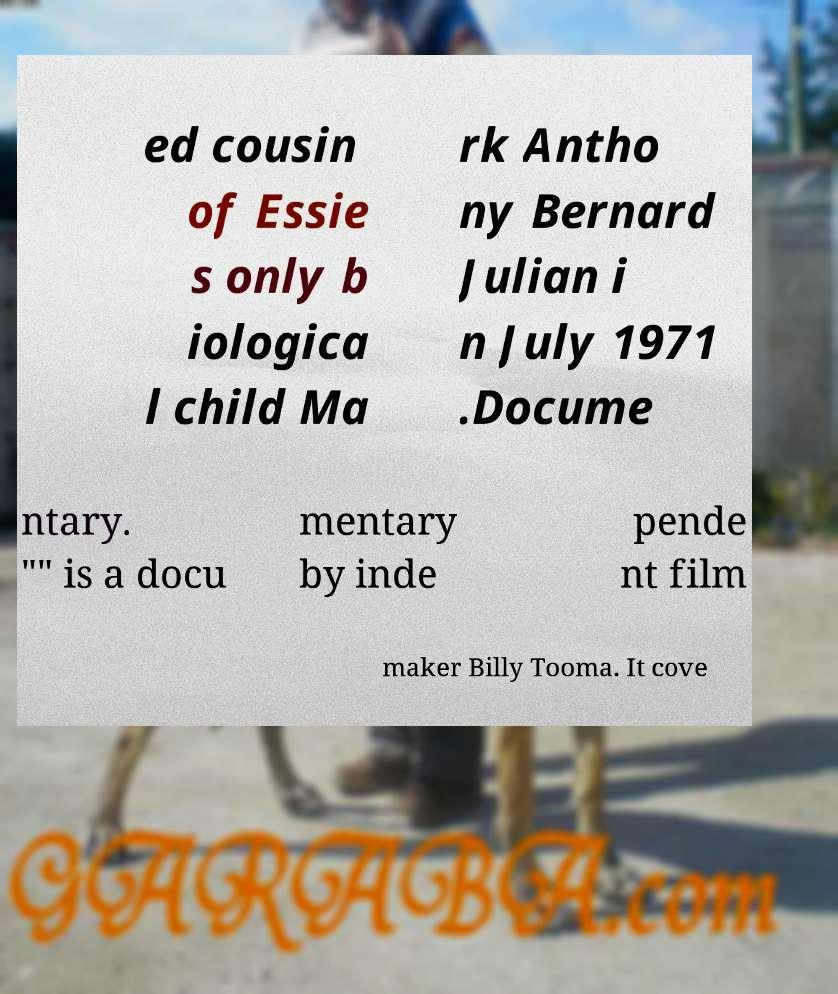Please read and relay the text visible in this image. What does it say? ed cousin of Essie s only b iologica l child Ma rk Antho ny Bernard Julian i n July 1971 .Docume ntary. "" is a docu mentary by inde pende nt film maker Billy Tooma. It cove 